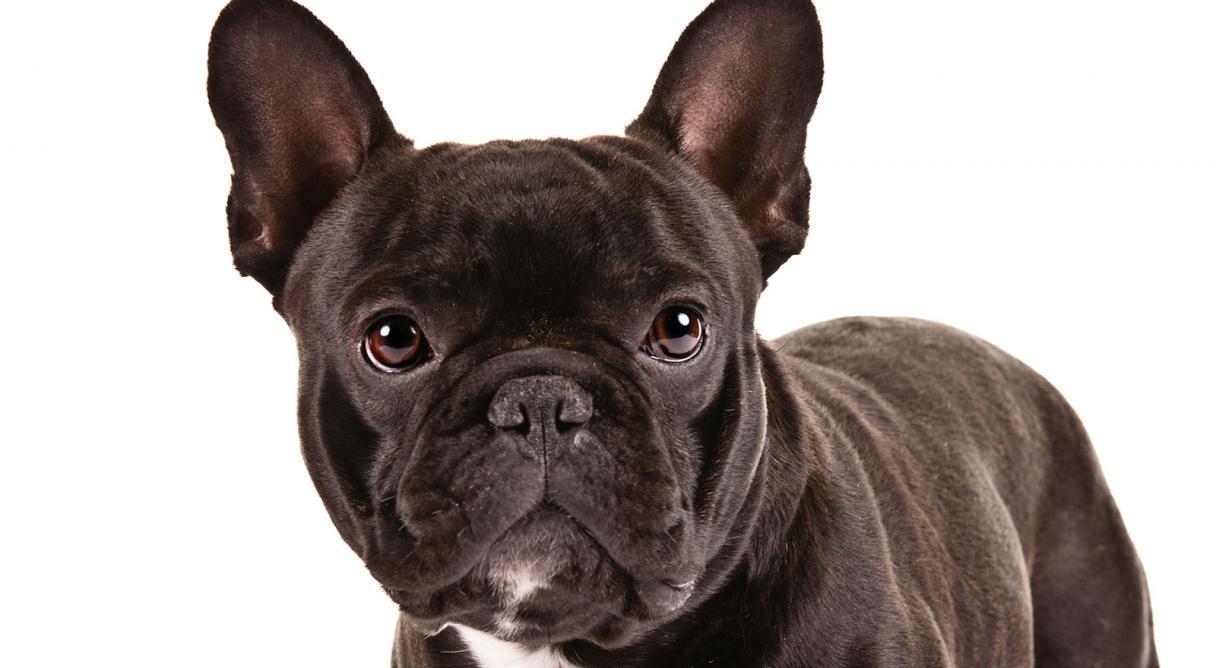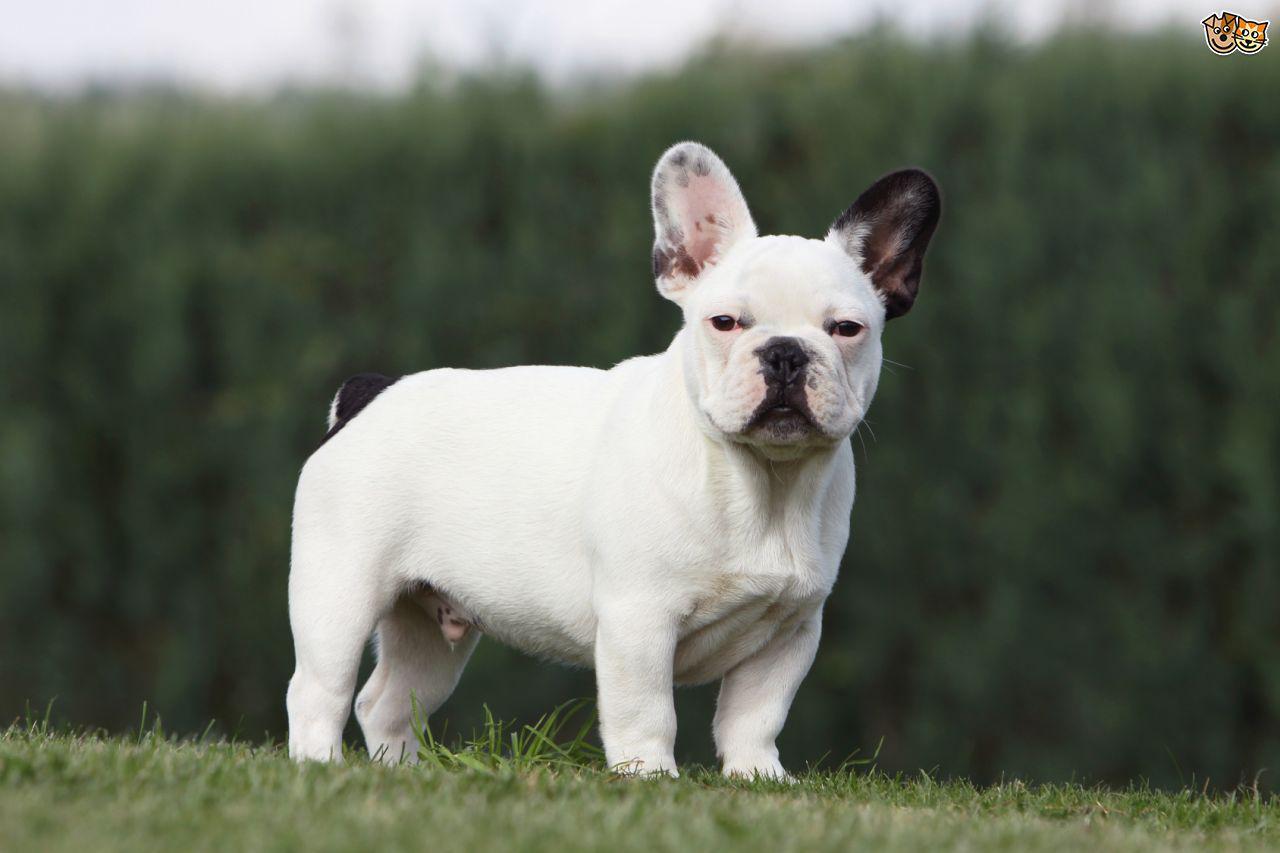The first image is the image on the left, the second image is the image on the right. Assess this claim about the two images: "There are two young dogs.". Correct or not? Answer yes or no. Yes. 